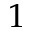<formula> <loc_0><loc_0><loc_500><loc_500>1</formula> 